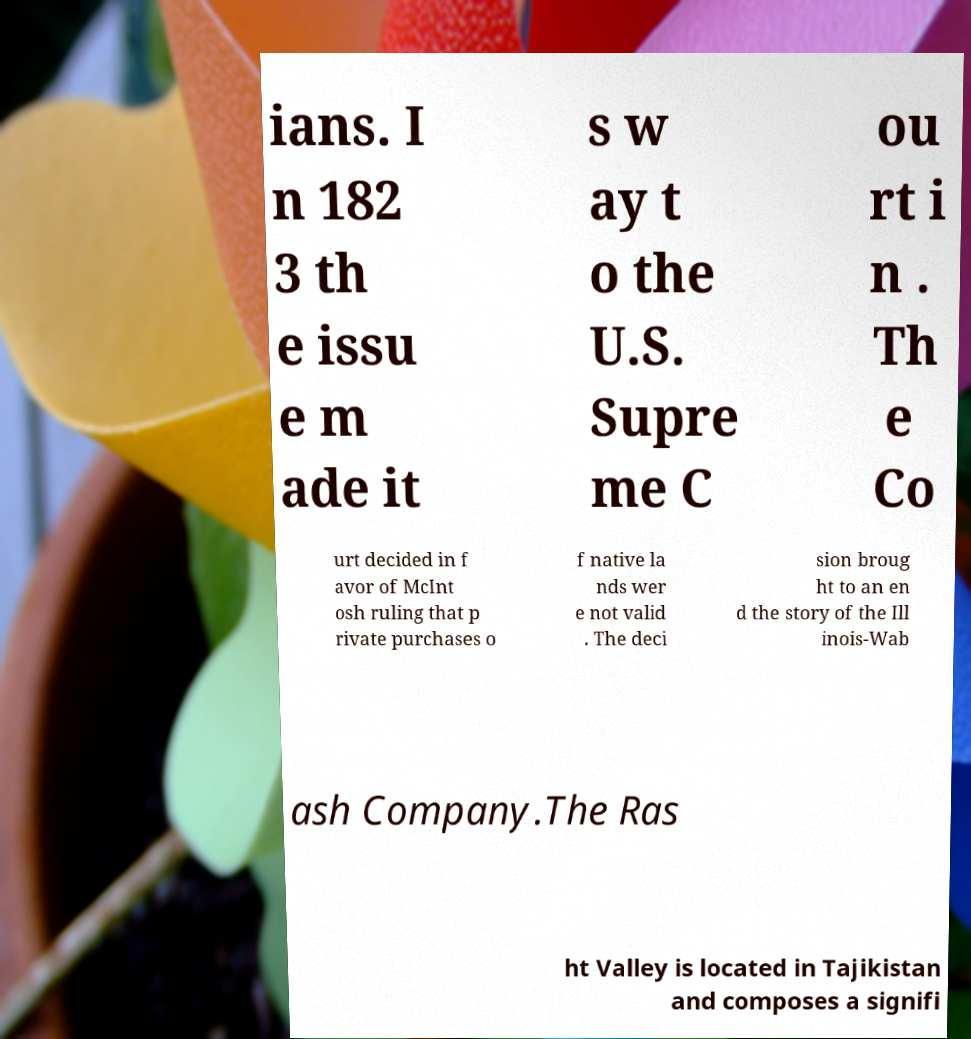I need the written content from this picture converted into text. Can you do that? ians. I n 182 3 th e issu e m ade it s w ay t o the U.S. Supre me C ou rt i n . Th e Co urt decided in f avor of McInt osh ruling that p rivate purchases o f native la nds wer e not valid . The deci sion broug ht to an en d the story of the Ill inois-Wab ash Company.The Ras ht Valley is located in Tajikistan and composes a signifi 